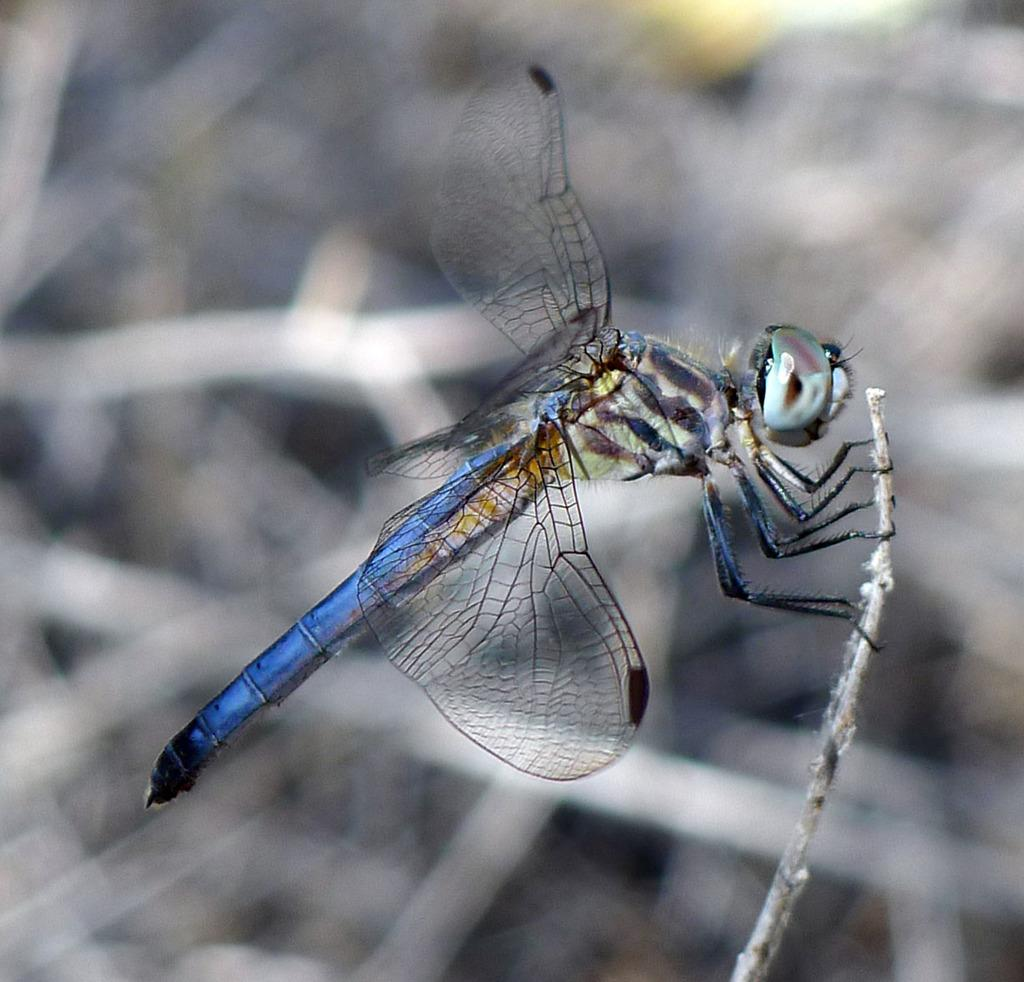Where was the image taken? The image was taken outdoors. What can be observed about the background of the image? The background of the image is blurred. What is the main subject of the image? There is a dragonfly in the image. Can you describe the dragonfly's position in the image? The dragonfly is on a stem. What type of crime is being committed by the dragonfly in the image? There is no crime being committed by the dragonfly in the image; it is simply perched on a stem. How does the dragonfly use the brake while on the stem in the image? Dragonflies do not have brakes, and the image does not depict any action or movement by the dragonfly. 